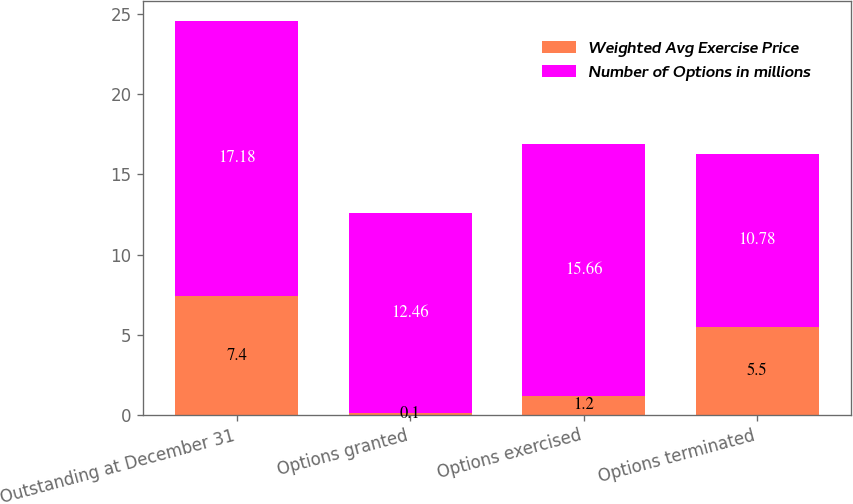<chart> <loc_0><loc_0><loc_500><loc_500><stacked_bar_chart><ecel><fcel>Outstanding at December 31<fcel>Options granted<fcel>Options exercised<fcel>Options terminated<nl><fcel>Weighted Avg Exercise Price<fcel>7.4<fcel>0.1<fcel>1.2<fcel>5.5<nl><fcel>Number of Options in millions<fcel>17.18<fcel>12.46<fcel>15.66<fcel>10.78<nl></chart> 